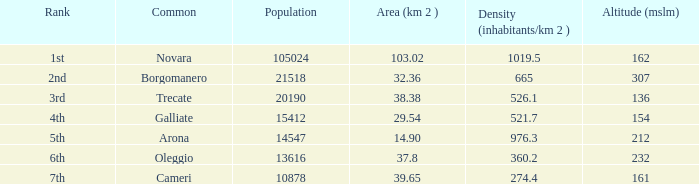Where does the common of Galliate rank in population? 4th. 